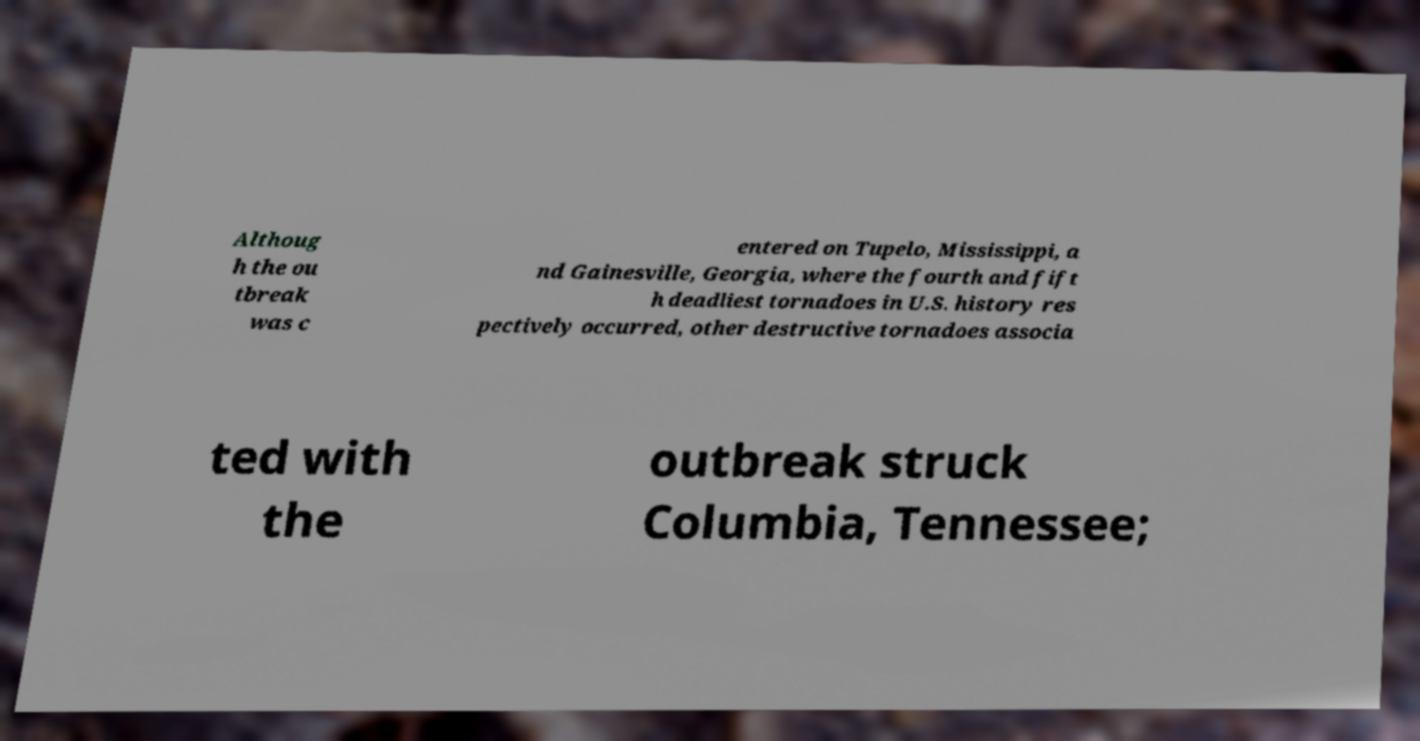Please identify and transcribe the text found in this image. Althoug h the ou tbreak was c entered on Tupelo, Mississippi, a nd Gainesville, Georgia, where the fourth and fift h deadliest tornadoes in U.S. history res pectively occurred, other destructive tornadoes associa ted with the outbreak struck Columbia, Tennessee; 